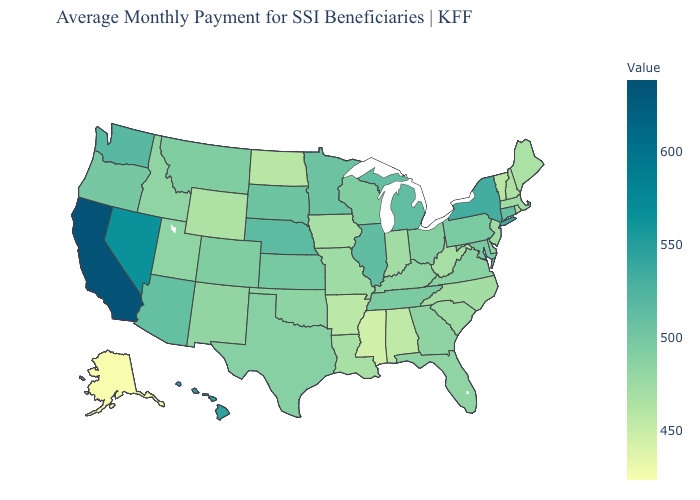Which states have the lowest value in the South?
Give a very brief answer. Mississippi. Which states have the lowest value in the USA?
Keep it brief. Alaska. Does Texas have a lower value than Hawaii?
Write a very short answer. Yes. Is the legend a continuous bar?
Answer briefly. Yes. Among the states that border Washington , does Idaho have the lowest value?
Short answer required. Yes. Among the states that border Iowa , does Nebraska have the highest value?
Quick response, please. Yes. Which states have the lowest value in the South?
Quick response, please. Mississippi. Among the states that border Wyoming , which have the highest value?
Give a very brief answer. Nebraska. Does North Carolina have the lowest value in the South?
Answer briefly. No. Does North Dakota have the lowest value in the MidWest?
Be succinct. Yes. 